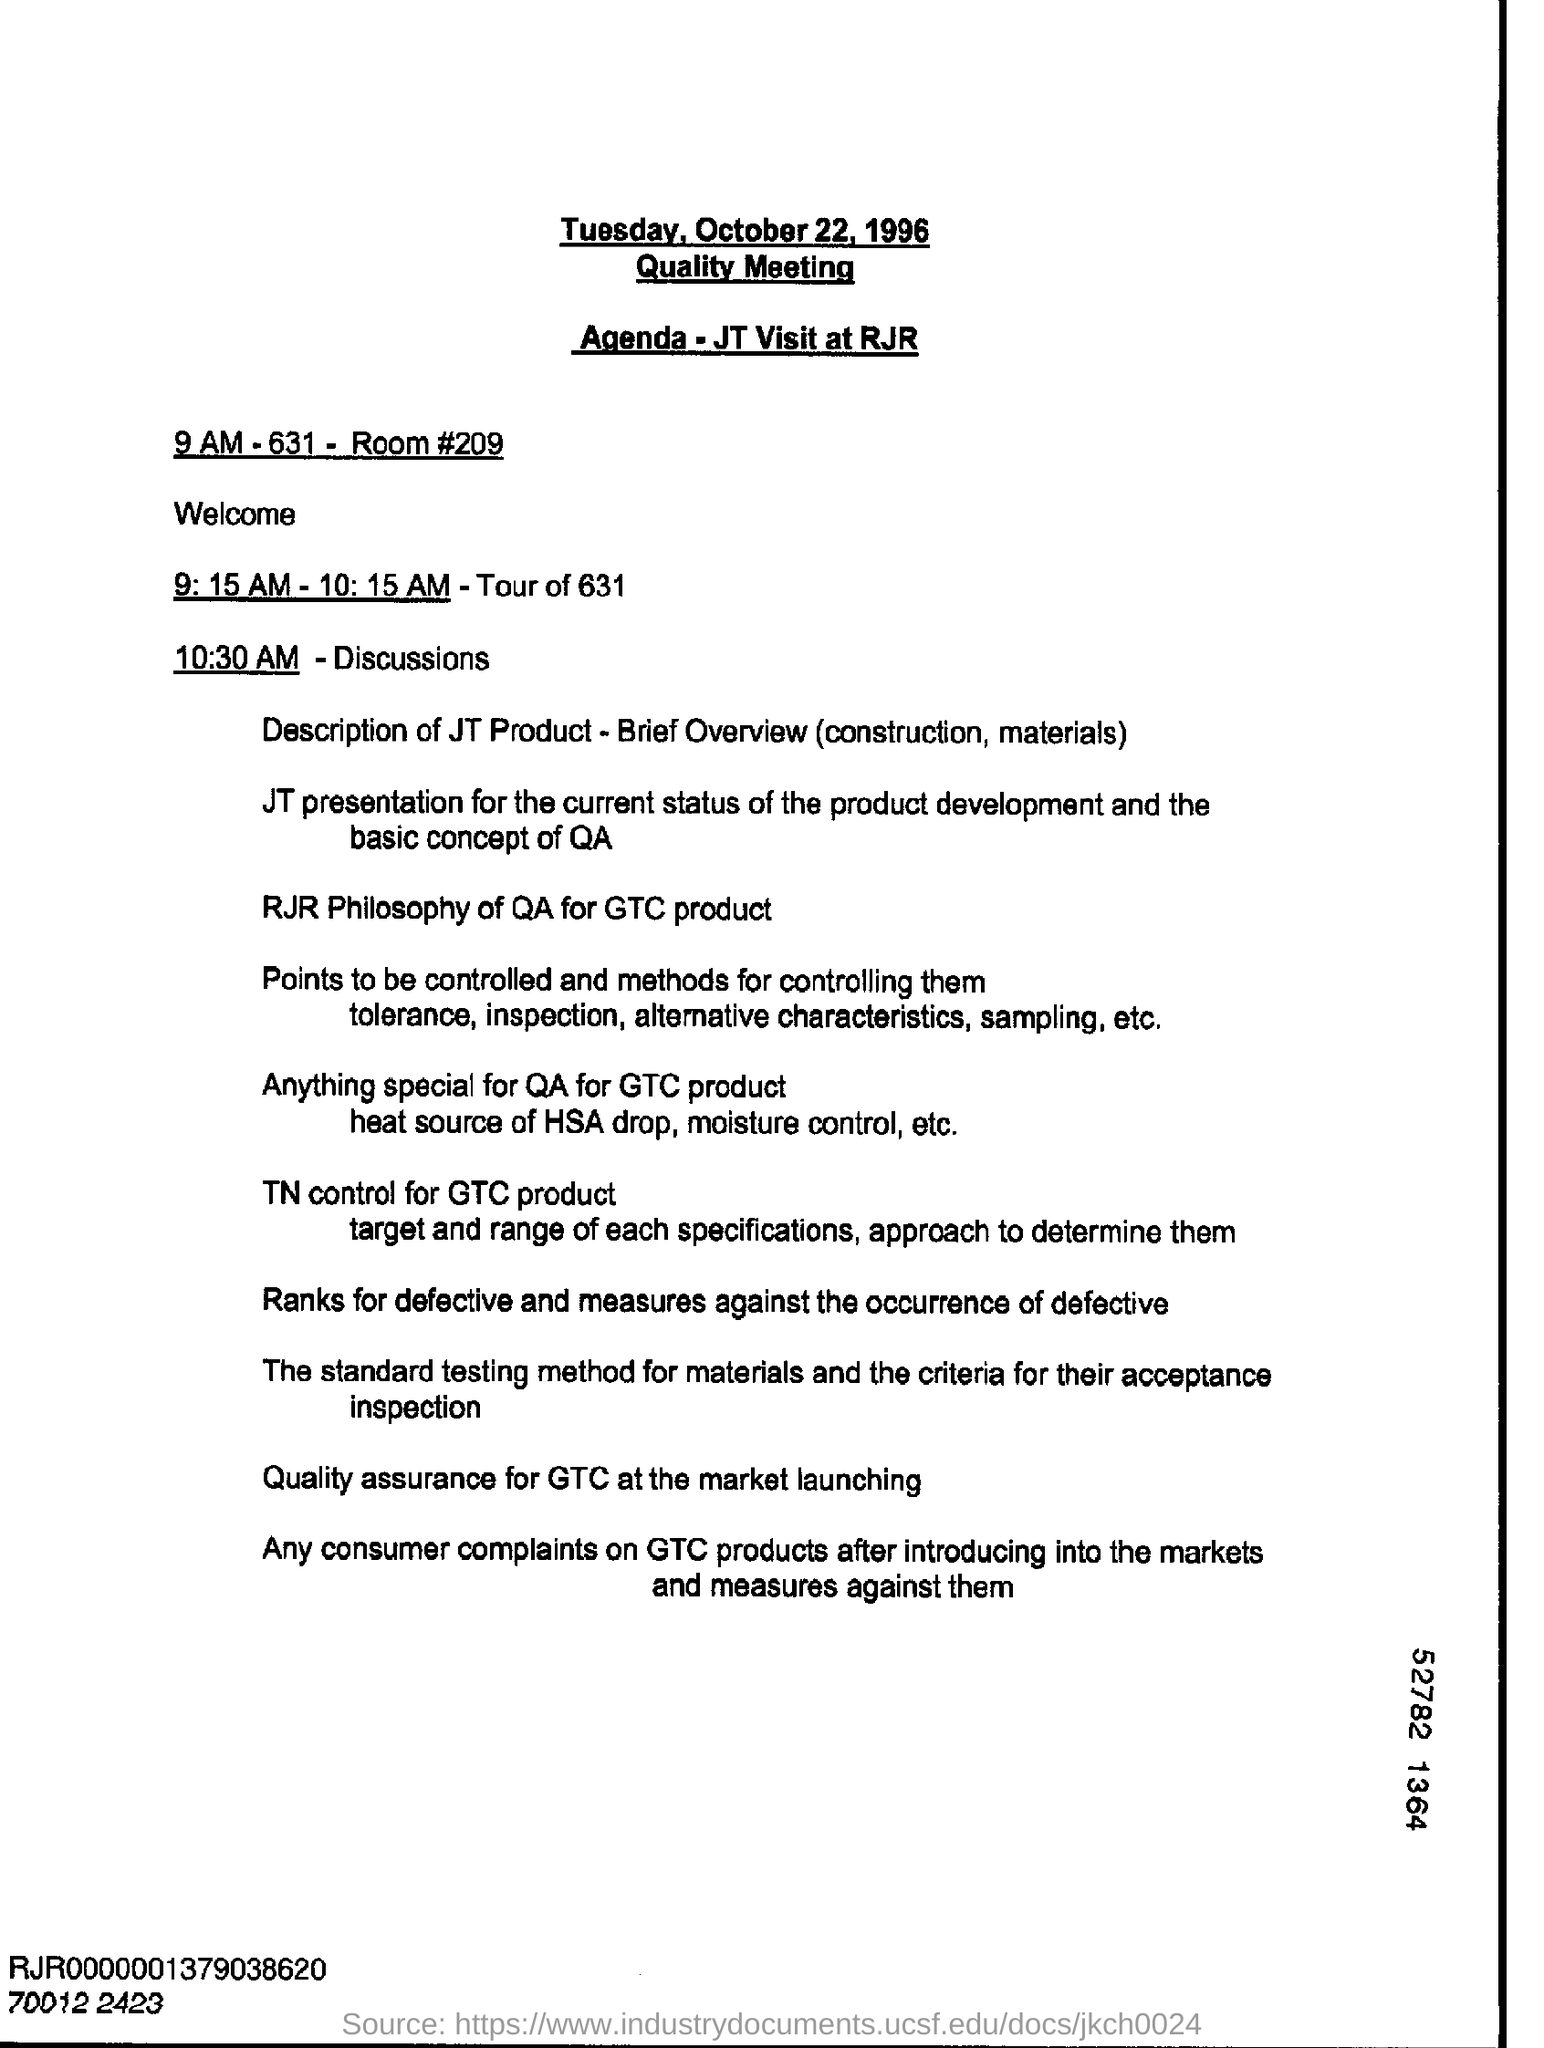Identify some key points in this picture. The Quality Meeting is scheduled for Tuesday, October 22, 1996. The room number is 209. 